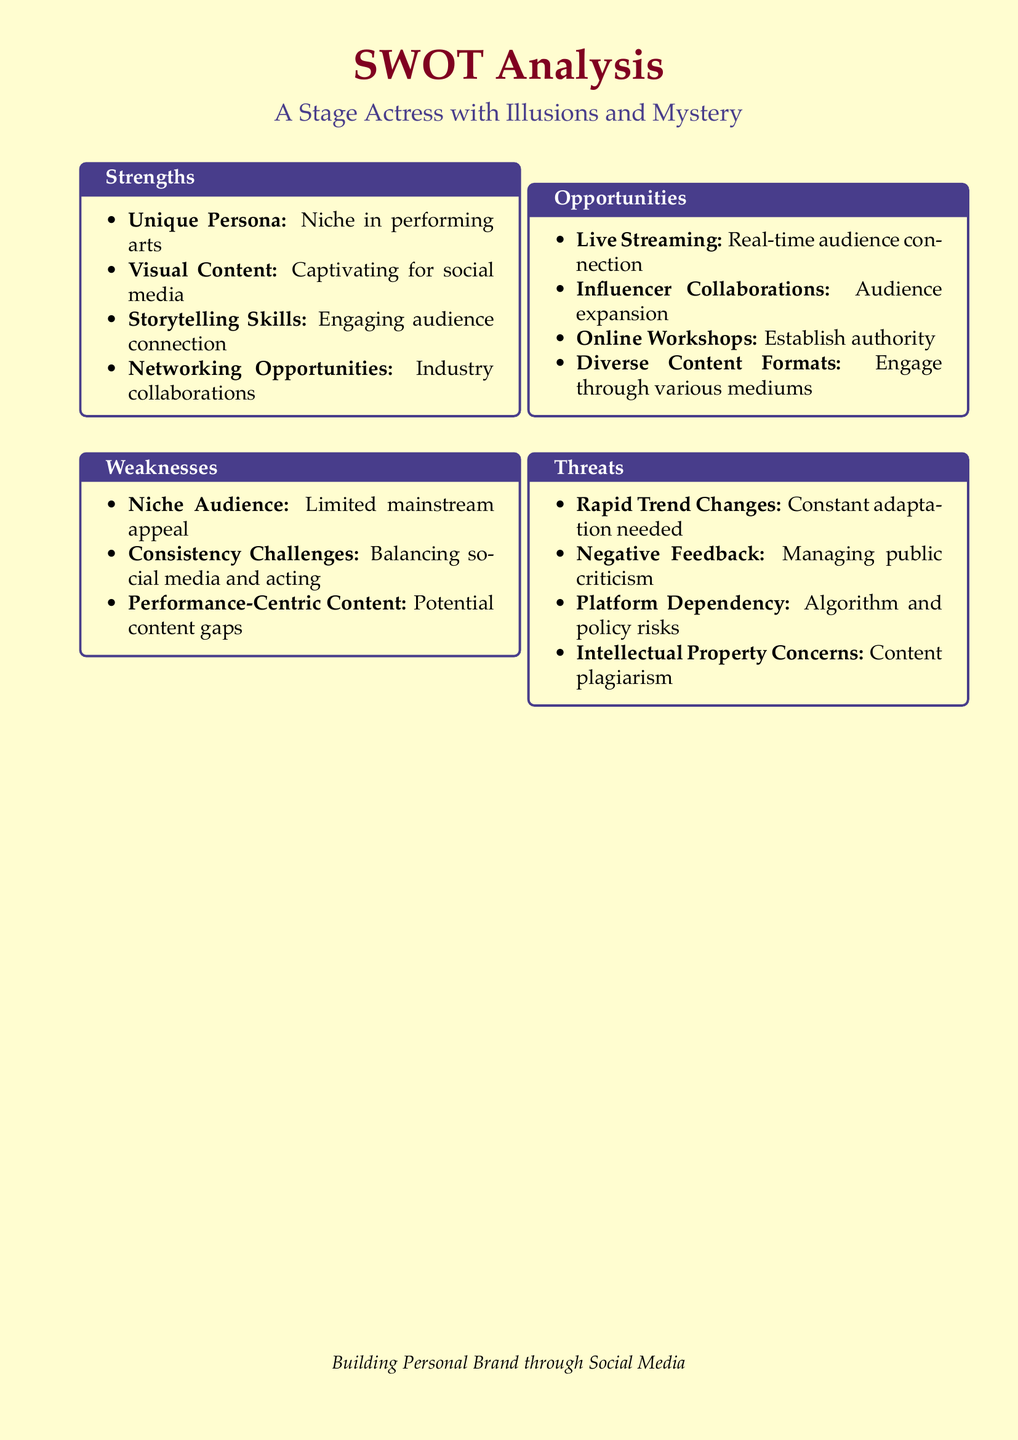What is the main purpose of the document? The document presents a SWOT analysis for building a personal brand through social media specifically for a stage actress.
Answer: SWOT analysis How many strengths are identified in the analysis? The strengths section lists four distinct points describing advantages related to personal branding.
Answer: 4 What potential threat involves public perception? The threats section highlights negative feedback as a concern that could affect the actress's branding.
Answer: Negative Feedback Which content format is suggested to engage the audience? The opportunities section mentions diverse content formats as a method to connect with the audience.
Answer: Diverse Content Formats What is a specific challenge listed under weaknesses? The weaknesses section mentions consistency challenges in managing both social media presence and acting commitments.
Answer: Consistency Challenges Which strategy is mentioned for real-time audience engagement? Live streaming is a specific opportunity identified for creating immediate interactions with the audience.
Answer: Live Streaming What unique quality does the actress’s persona provide? The strengths section emphasizes her unique persona as a significant aspect that enhances her niche in the performing arts.
Answer: Unique Persona How many opportunities are presented in the analysis? The opportunities section outlines four different strategies that can be pursued to build a personal brand.
Answer: 4 